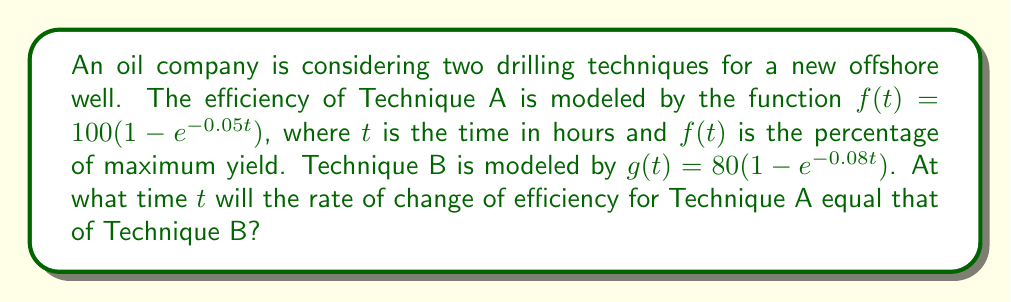Could you help me with this problem? To solve this problem, we need to follow these steps:

1) First, we need to find the derivatives of both functions to get the rate of change of efficiency:

   For Technique A: $f'(t) = 100(0.05e^{-0.05t})$
   For Technique B: $g'(t) = 80(0.08e^{-0.08t})$

2) We want to find when these rates are equal, so we set up the equation:

   $f'(t) = g'(t)$

3) Substituting our derivatives:

   $100(0.05e^{-0.05t}) = 80(0.08e^{-0.08t})$

4) Simplify:

   $5e^{-0.05t} = 6.4e^{-0.08t}$

5) Take the natural log of both sides:

   $\ln(5) - 0.05t = \ln(6.4) - 0.08t$

6) Solve for $t$:

   $0.03t = \ln(6.4) - \ln(5)$
   $t = \frac{\ln(6.4) - \ln(5)}{0.03}$

7) Calculate the final answer:

   $t \approx 8.92$ hours
Answer: $8.92$ hours 